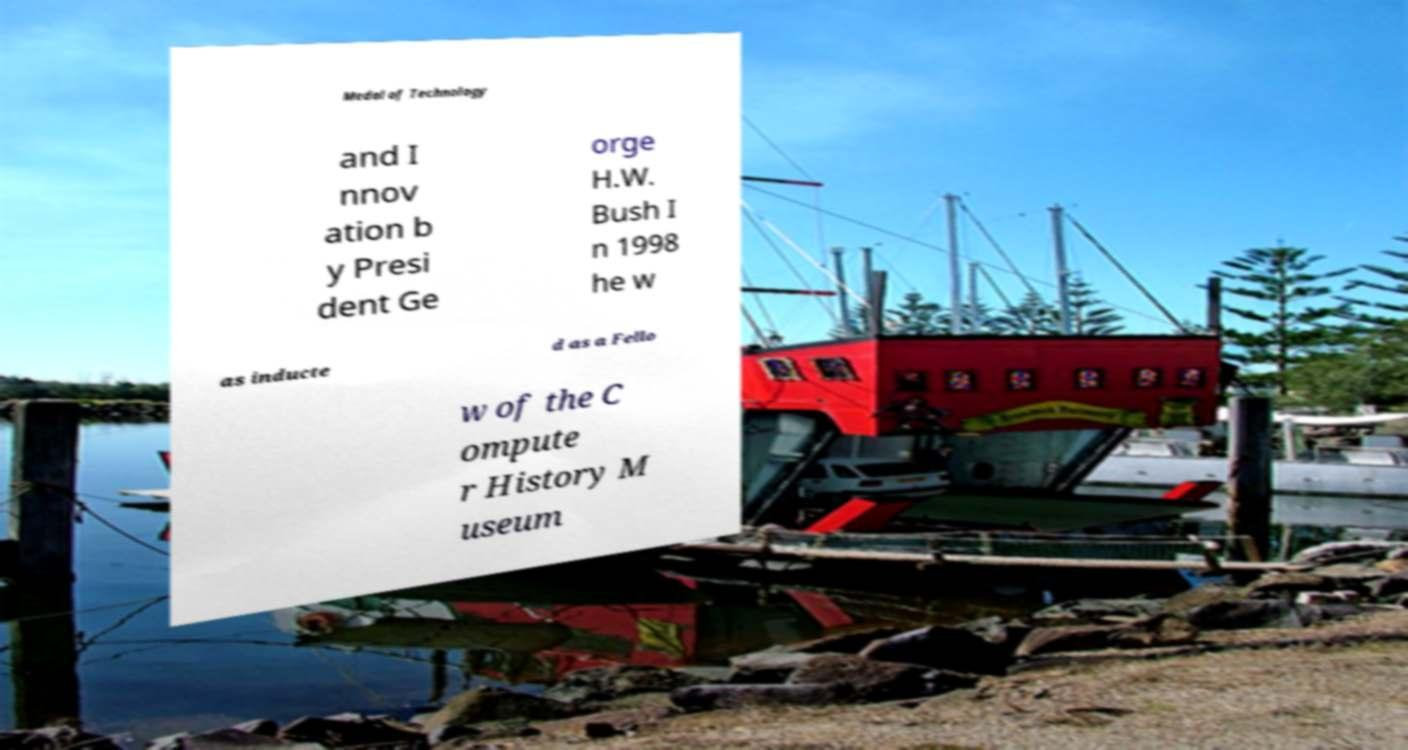Can you accurately transcribe the text from the provided image for me? Medal of Technology and I nnov ation b y Presi dent Ge orge H.W. Bush I n 1998 he w as inducte d as a Fello w of the C ompute r History M useum 